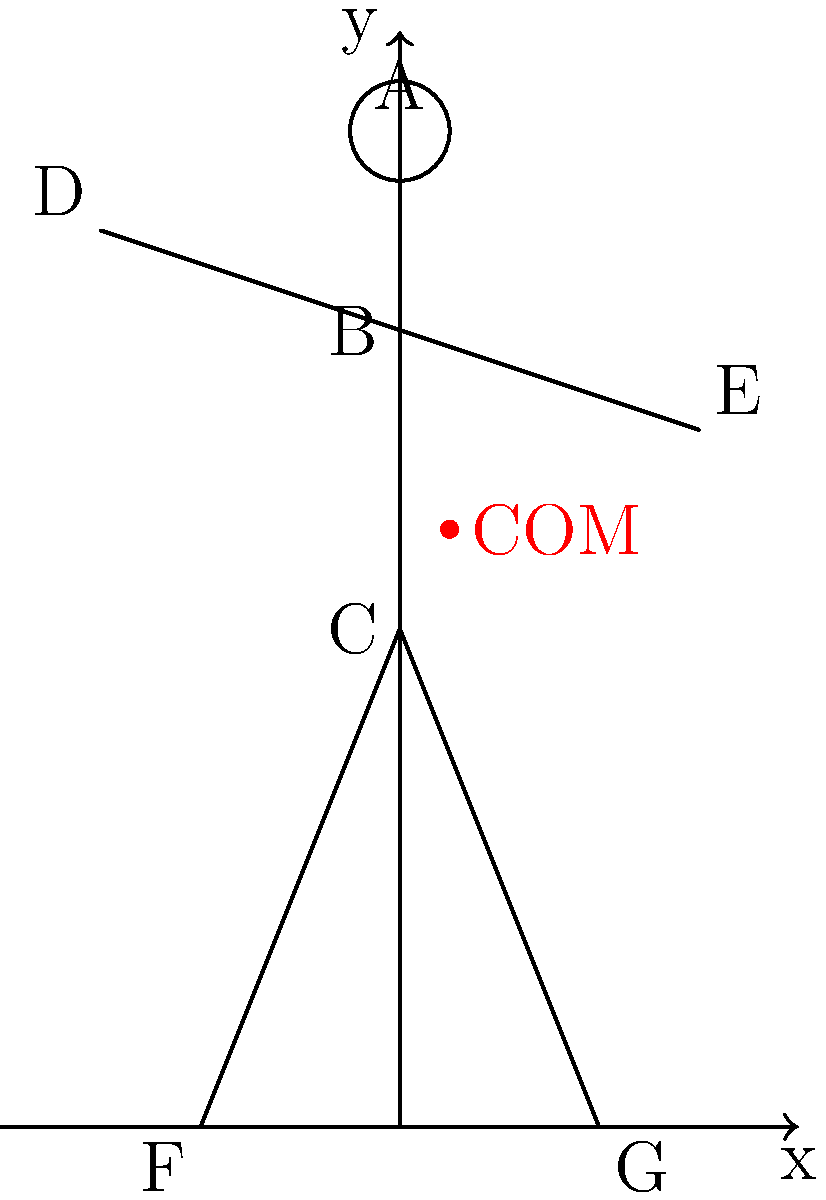A gymnast is holding a static pose as shown in the stick figure diagram. Given that the center of mass (COM) is located at coordinates (0.5, 6), which body segment is likely contributing the most to shifting the COM slightly to the right of the central axis? Explain your reasoning using the principles of center of mass calculation. To determine which body segment is contributing most to shifting the COM to the right, we need to consider the following steps:

1. Observe the position of body segments:
   - The head (A), shoulders (B), and hips (C) are aligned vertically at x = 0.
   - The left hand (D) is at x = -3, pulling slightly to the left.
   - The right hand (E) is at x = 3, pulling to the right.
   - The left foot (F) is at x = -2, pulling slightly to the left.
   - The right foot (G) is at x = 2, pulling slightly to the right.

2. Consider the mass distribution:
   - The torso (including head) typically accounts for about 50% of body mass.
   - Arms are about 5-6% of body mass each.
   - Legs are about 15-18% of body mass each.

3. Analyze the COM position:
   - The COM is at x = 0.5, indicating a slight shift to the right.
   - This shift must be caused by asymmetry in the limb positions.

4. Compare limb positions:
   - The arms show the greatest asymmetry in their x-coordinates.
   - The right arm (E) is positioned further from the central axis than the left arm (D).
   - The legs show less asymmetry and are closer to the central axis.

5. Consider leverage effect:
   - The right arm (E) is extended outward, creating a longer lever arm.
   - This increased distance from the central axis amplifies its effect on the COM.

6. Conclusion:
   The right arm (E) is likely contributing the most to shifting the COM to the right because:
   a) It has the largest positive x-coordinate.
   b) Arms have significant mass compared to their size.
   c) Its extended position creates a longer lever arm, magnifying its effect on the COM.
Answer: Right arm (point E) 